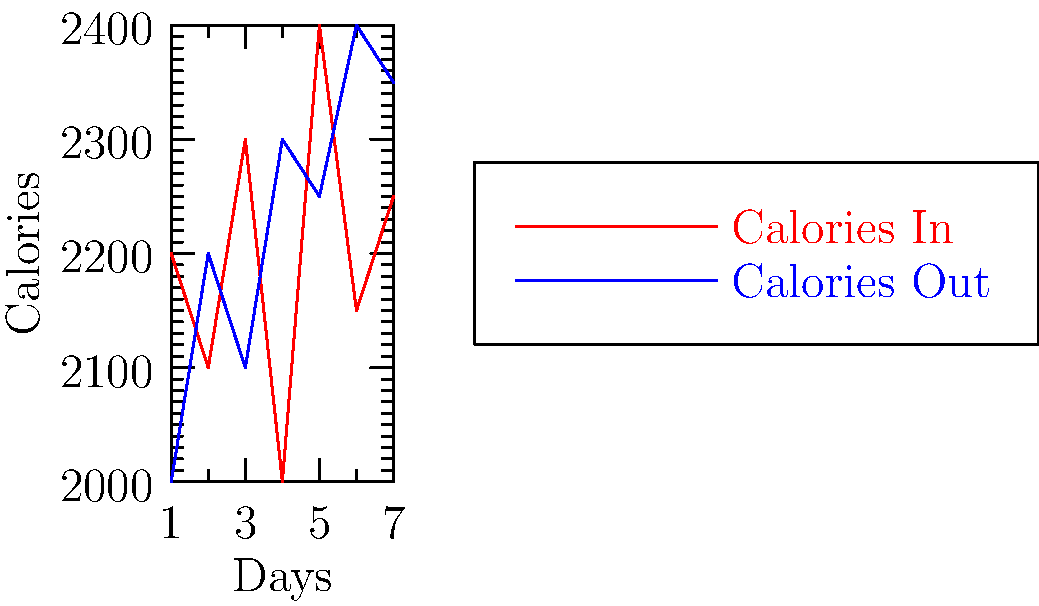Based on the line graph showing daily calorie intake (red) and expenditure (blue) over a week, on which day did the difference between calories consumed and burned reach its maximum? To find the day with the maximum difference between calories consumed and burned, we need to:

1. Calculate the difference between calories in and calories out for each day.
2. Identify the largest difference.

Let's go through each day:

Day 1: 2200 - 2000 = 200 calorie surplus
Day 2: 2100 - 2200 = -100 calorie deficit
Day 3: 2300 - 2100 = 200 calorie surplus
Day 4: 2000 - 2300 = -300 calorie deficit
Day 5: 2400 - 2250 = 150 calorie surplus
Day 6: 2150 - 2400 = -250 calorie deficit
Day 7: 2250 - 2350 = -100 calorie deficit

The largest absolute difference is 300 calories, which occurred on Day 4.
Answer: Day 4 